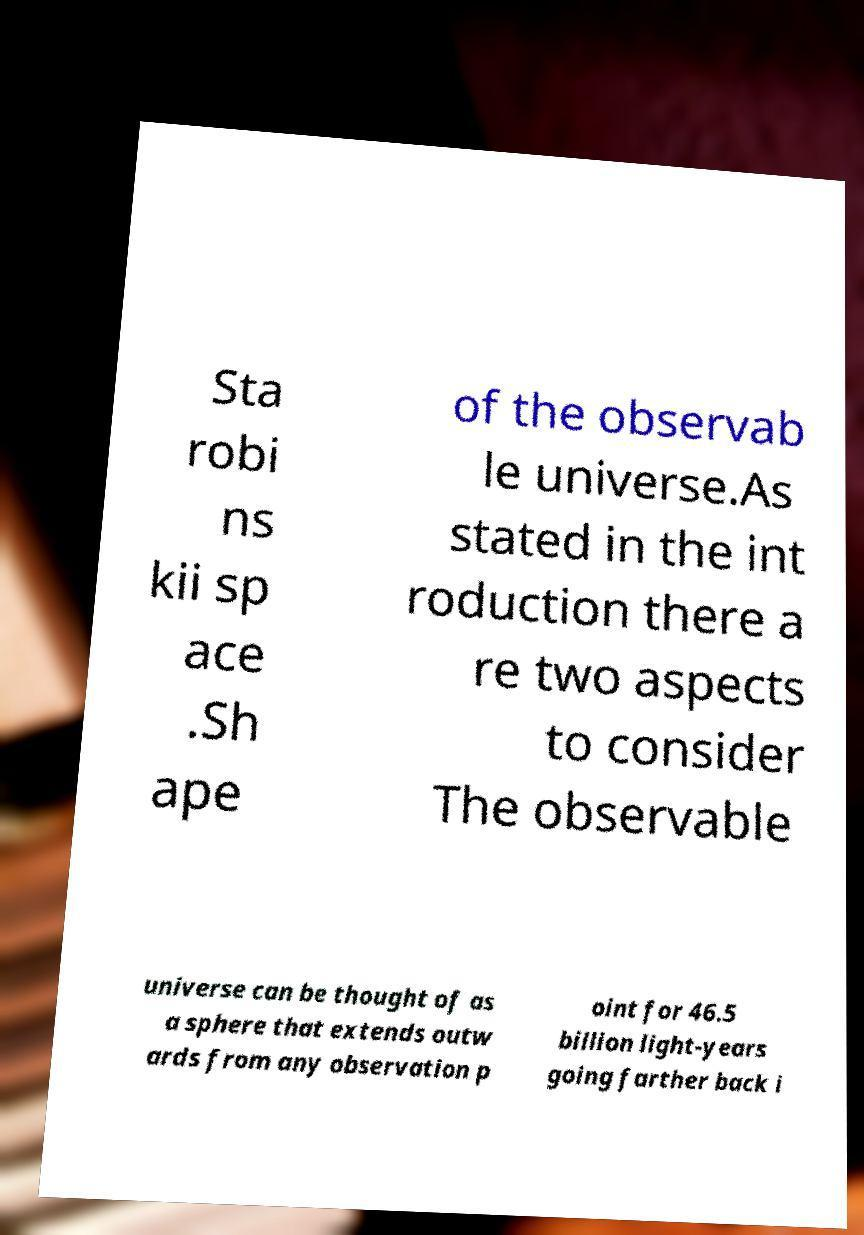For documentation purposes, I need the text within this image transcribed. Could you provide that? Sta robi ns kii sp ace .Sh ape of the observab le universe.As stated in the int roduction there a re two aspects to consider The observable universe can be thought of as a sphere that extends outw ards from any observation p oint for 46.5 billion light-years going farther back i 